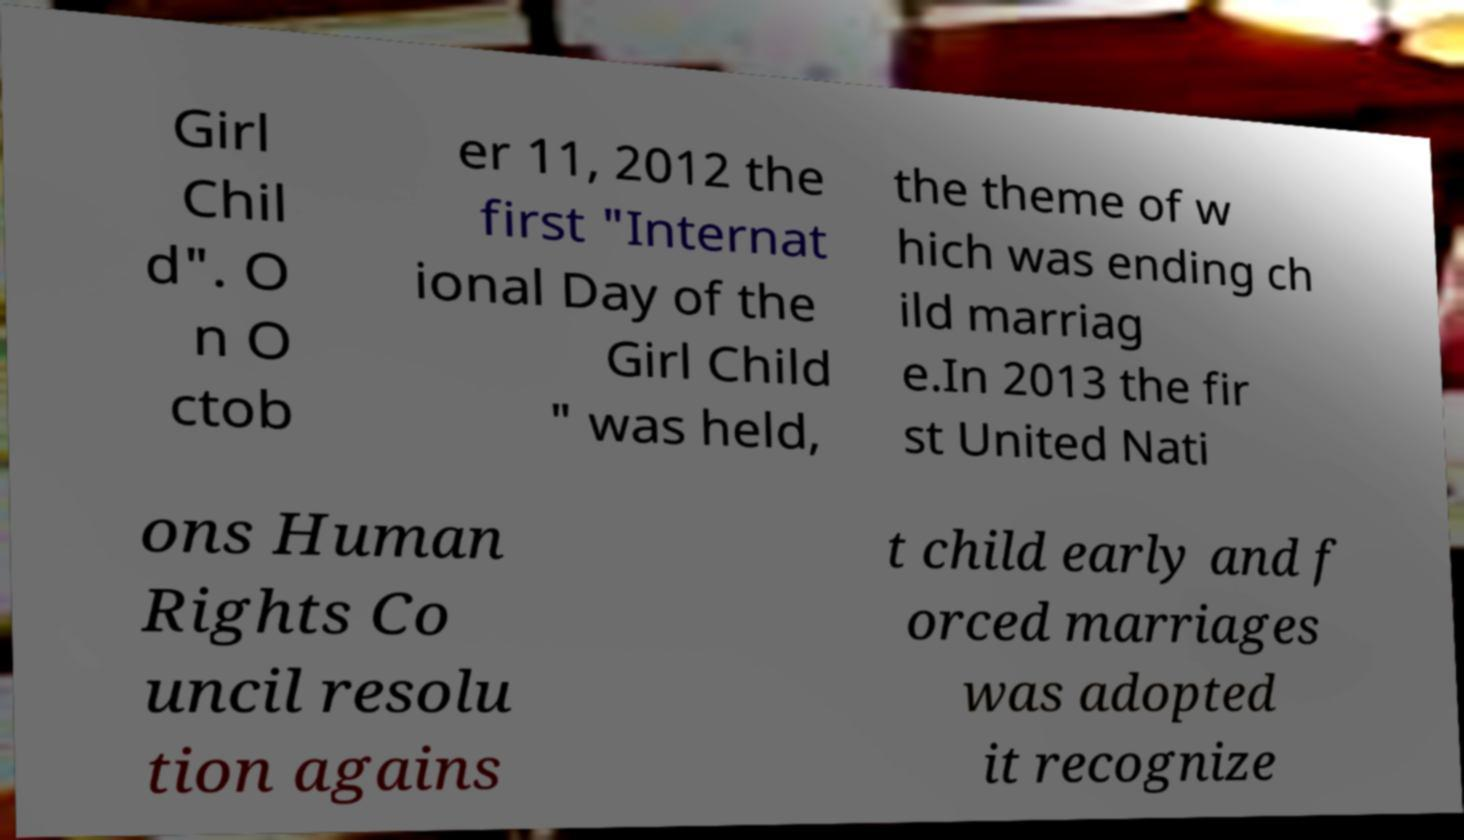I need the written content from this picture converted into text. Can you do that? Girl Chil d". O n O ctob er 11, 2012 the first "Internat ional Day of the Girl Child " was held, the theme of w hich was ending ch ild marriag e.In 2013 the fir st United Nati ons Human Rights Co uncil resolu tion agains t child early and f orced marriages was adopted it recognize 